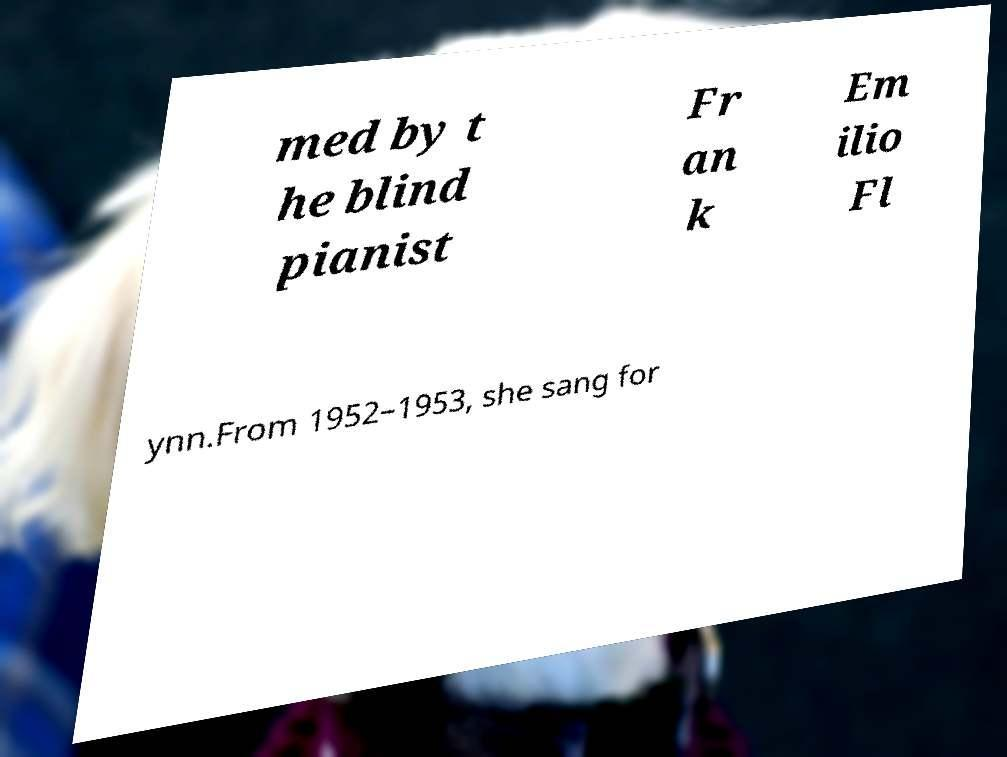Could you assist in decoding the text presented in this image and type it out clearly? med by t he blind pianist Fr an k Em ilio Fl ynn.From 1952–1953, she sang for 